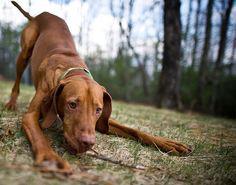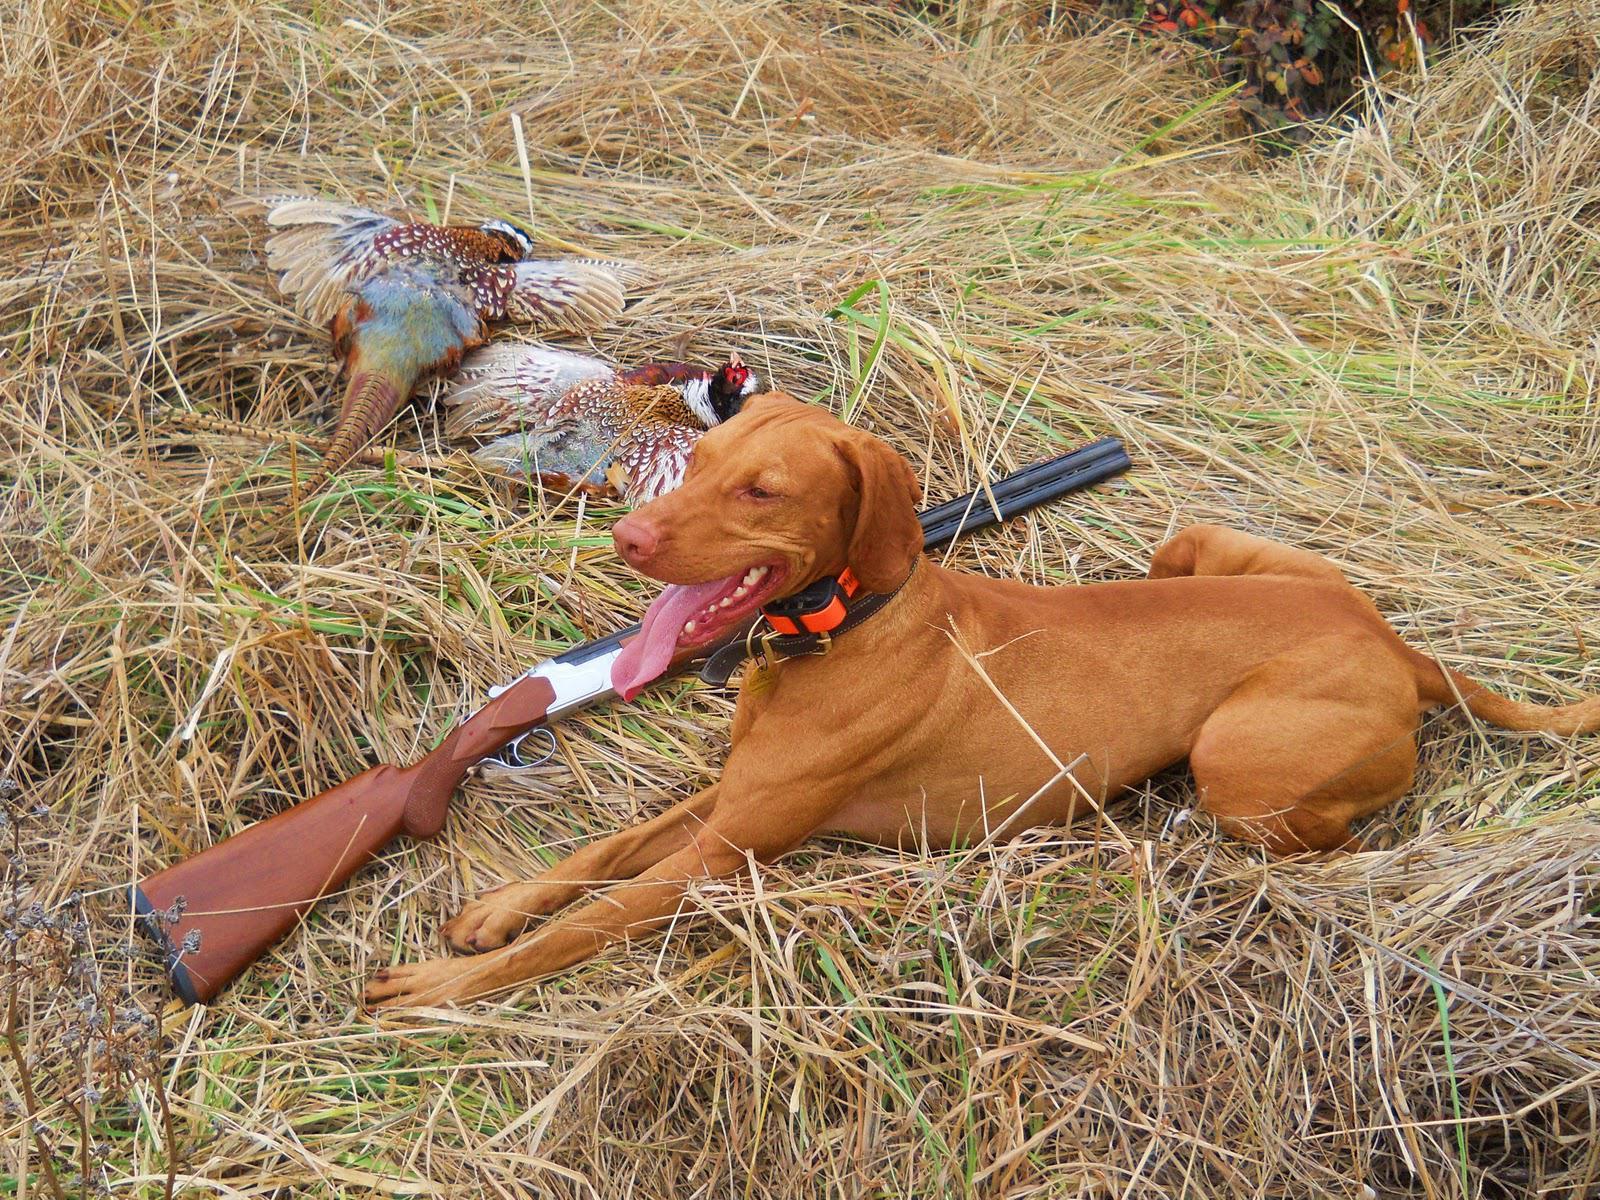The first image is the image on the left, the second image is the image on the right. Examine the images to the left and right. Is the description "In at least one image there is a shotgun behind a dog with his tongue stuck out." accurate? Answer yes or no. Yes. The first image is the image on the left, the second image is the image on the right. Analyze the images presented: Is the assertion "A dog is laying down." valid? Answer yes or no. Yes. 